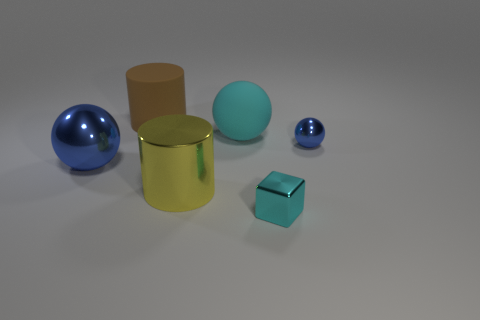Add 1 large matte balls. How many objects exist? 7 Subtract all cylinders. How many objects are left? 4 Subtract all tiny cyan rubber things. Subtract all spheres. How many objects are left? 3 Add 6 tiny metal spheres. How many tiny metal spheres are left? 7 Add 5 large gray things. How many large gray things exist? 5 Subtract 0 cyan cylinders. How many objects are left? 6 